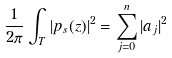<formula> <loc_0><loc_0><loc_500><loc_500>\frac { 1 } { 2 \pi } \int _ { T } | p _ { s } ( z ) | ^ { 2 } = \sum _ { j = 0 } ^ { n } | a _ { j } | ^ { 2 }</formula> 